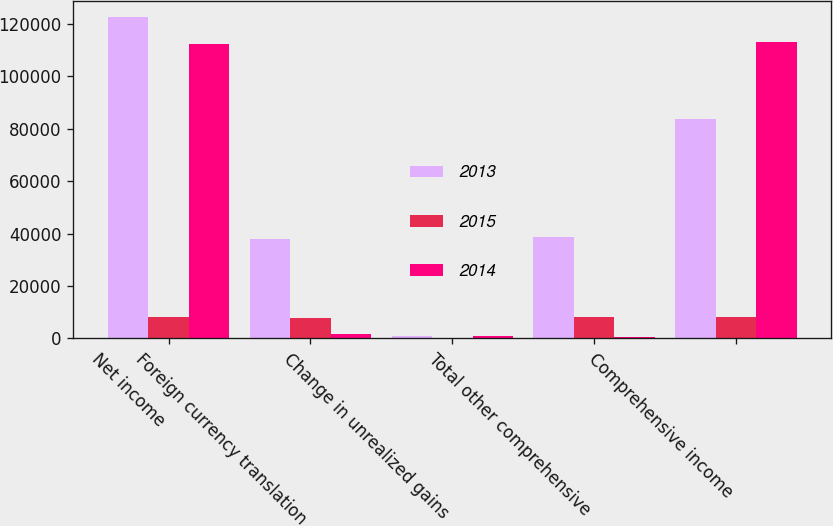Convert chart to OTSL. <chart><loc_0><loc_0><loc_500><loc_500><stacked_bar_chart><ecel><fcel>Net income<fcel>Foreign currency translation<fcel>Change in unrealized gains<fcel>Total other comprehensive<fcel>Comprehensive income<nl><fcel>2013<fcel>122641<fcel>37887<fcel>975<fcel>38862<fcel>83779<nl><fcel>2015<fcel>8021<fcel>7768<fcel>253<fcel>8021<fcel>8021<nl><fcel>2014<fcel>112403<fcel>1772<fcel>1116<fcel>656<fcel>113059<nl></chart> 